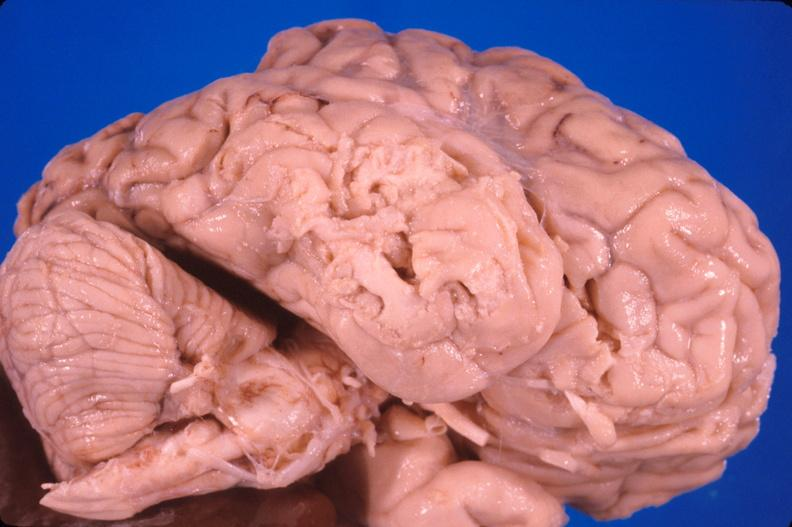does this image show brain, old infarcts, embolic?
Answer the question using a single word or phrase. Yes 